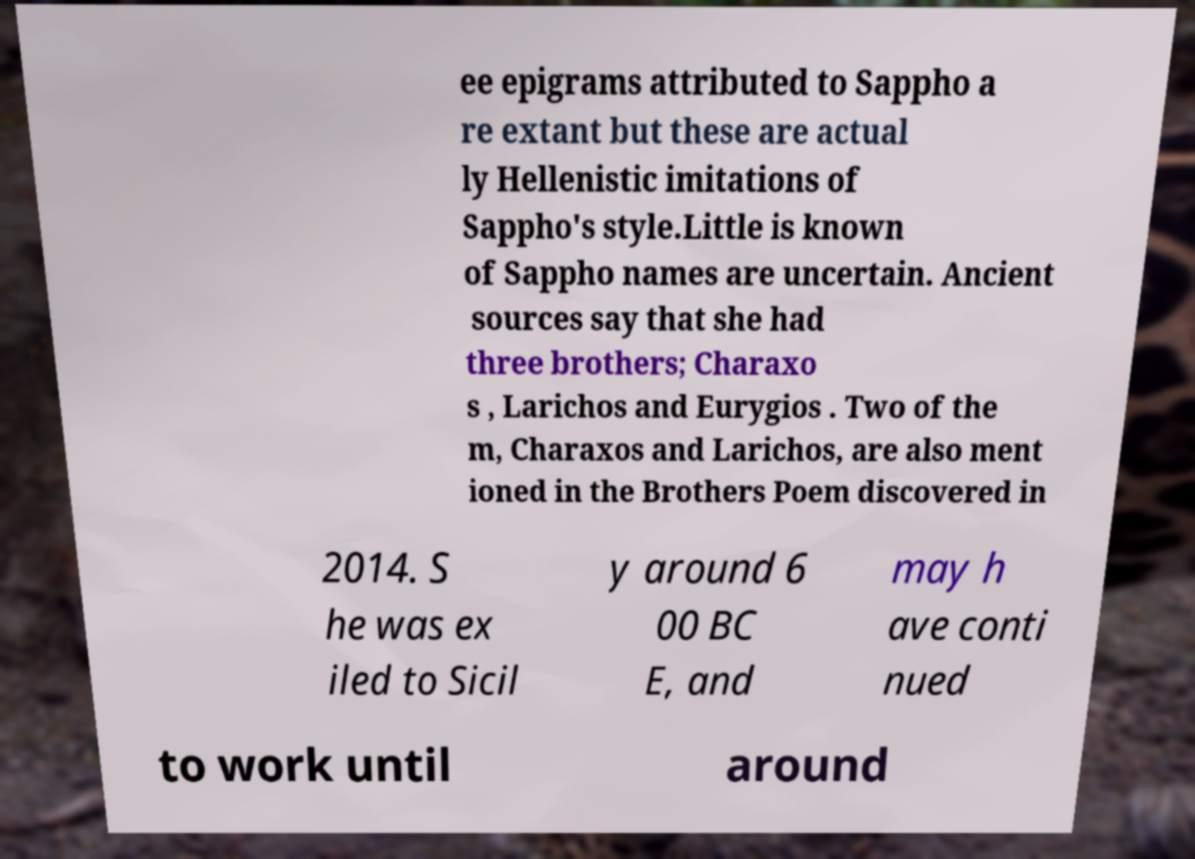Can you read and provide the text displayed in the image?This photo seems to have some interesting text. Can you extract and type it out for me? ee epigrams attributed to Sappho a re extant but these are actual ly Hellenistic imitations of Sappho's style.Little is known of Sappho names are uncertain. Ancient sources say that she had three brothers; Charaxo s , Larichos and Eurygios . Two of the m, Charaxos and Larichos, are also ment ioned in the Brothers Poem discovered in 2014. S he was ex iled to Sicil y around 6 00 BC E, and may h ave conti nued to work until around 